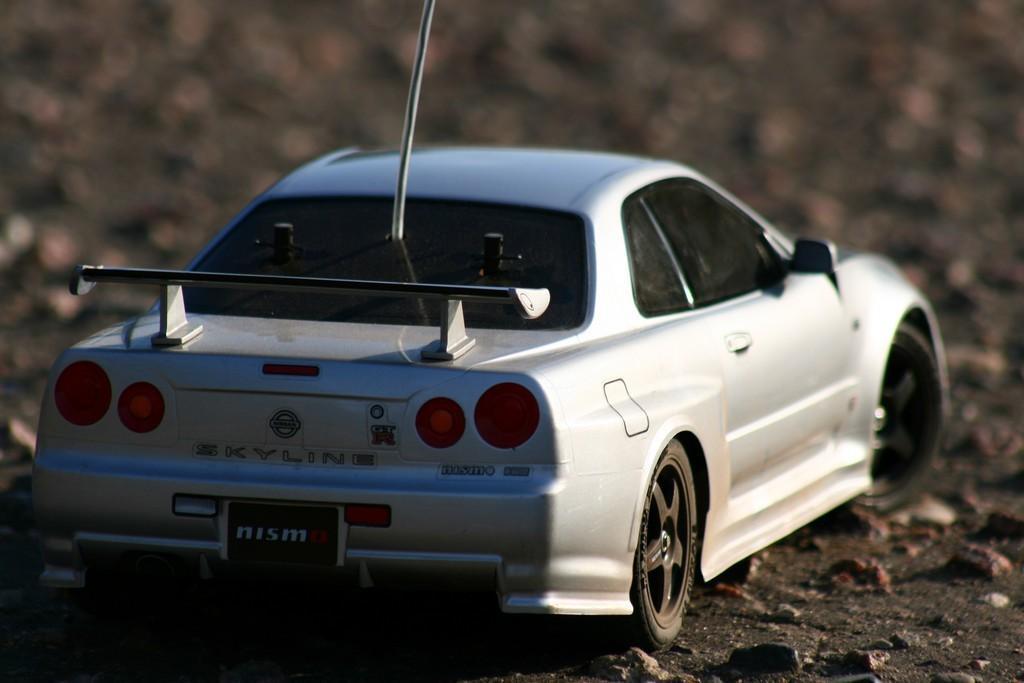Can you describe this image briefly? In this picture, we see a toy car. It is in white color. At the bottom, we see the stones. In the background, it is grey in color and this picture is blurred in the background. 